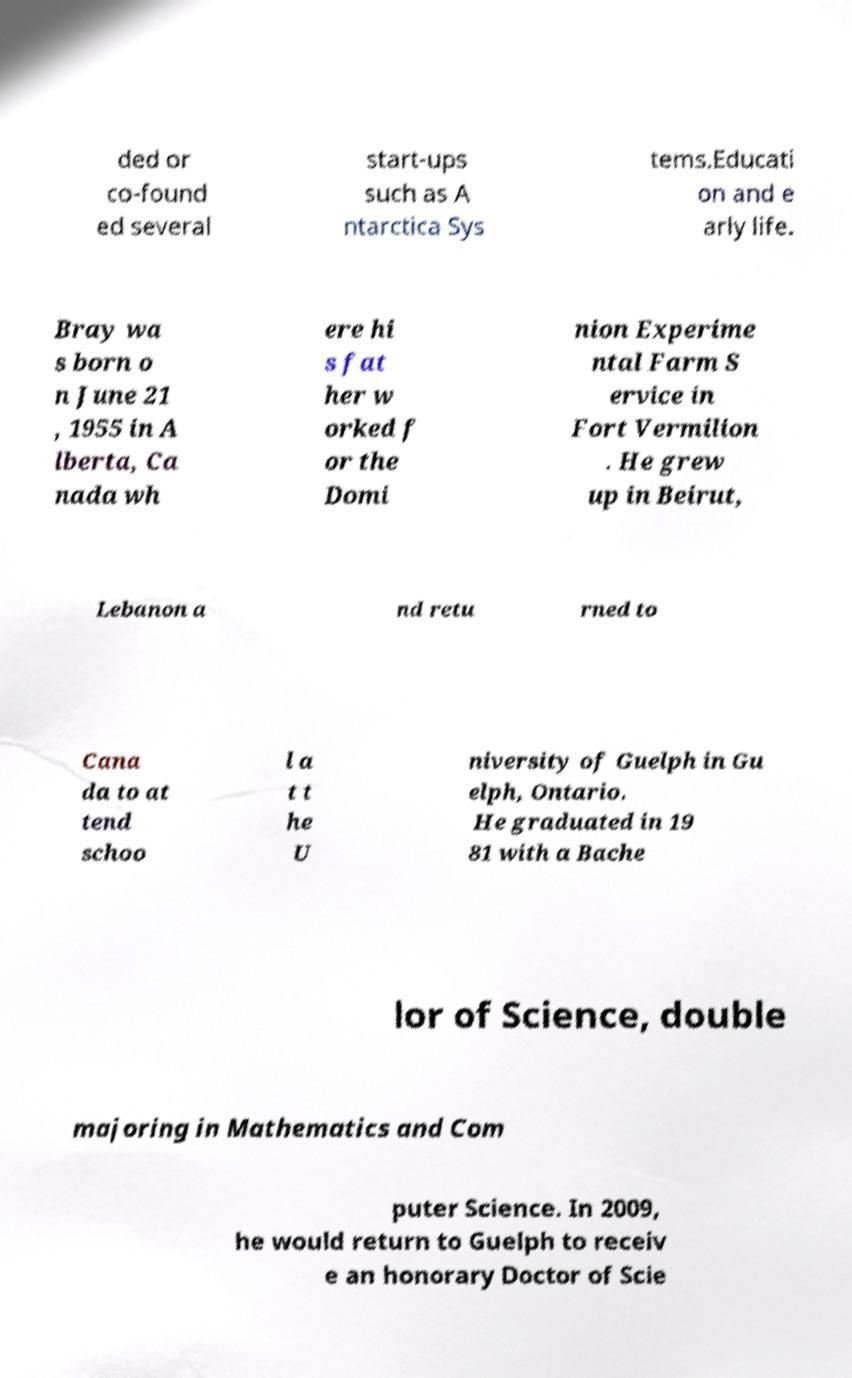Can you accurately transcribe the text from the provided image for me? ded or co-found ed several start-ups such as A ntarctica Sys tems.Educati on and e arly life. Bray wa s born o n June 21 , 1955 in A lberta, Ca nada wh ere hi s fat her w orked f or the Domi nion Experime ntal Farm S ervice in Fort Vermilion . He grew up in Beirut, Lebanon a nd retu rned to Cana da to at tend schoo l a t t he U niversity of Guelph in Gu elph, Ontario. He graduated in 19 81 with a Bache lor of Science, double majoring in Mathematics and Com puter Science. In 2009, he would return to Guelph to receiv e an honorary Doctor of Scie 